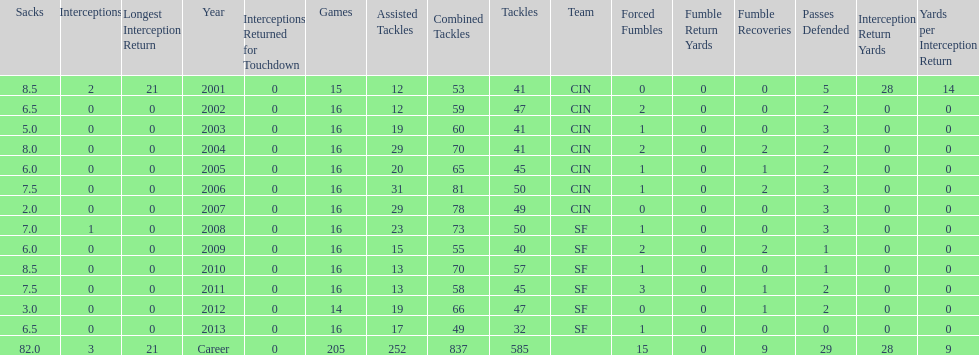What is the only season he has fewer than three sacks? 2007. 